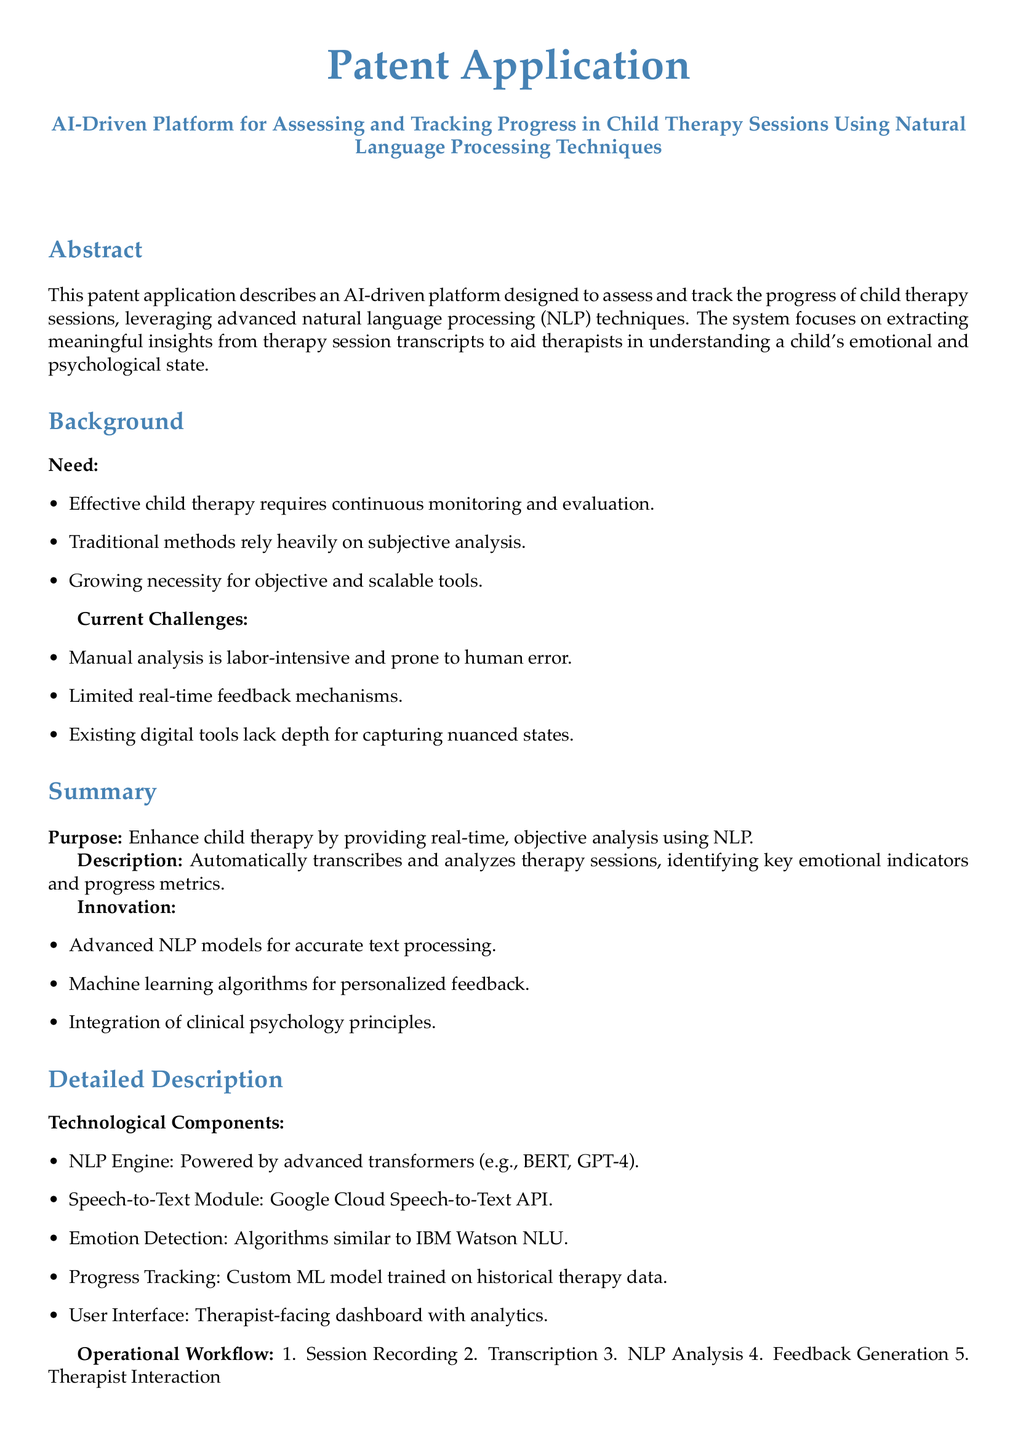What is the title of the patent application? The title is explicitly mentioned at the beginning of the document as "AI-Driven Platform for Assessing and Tracking Progress in Child Therapy Sessions Using Natural Language Processing Techniques".
Answer: AI-Driven Platform for Assessing and Tracking Progress in Child Therapy Sessions Using Natural Language Processing Techniques What technology powers the NLP Engine? The NLP Engine is powered by advanced transformers, specifically noted as BERT and GPT-4 in the document.
Answer: BERT, GPT-4 What is identified as a current challenge in child therapy? The document lists several current challenges, including manual analysis being labor-intensive and prone to human error.
Answer: Manual analysis being labor-intensive and prone to human error What therapy-related purpose does the platform aim to enhance? The purpose specified in the document is to enhance child therapy by providing real-time, objective analysis using NLP.
Answer: Real-time, objective analysis How many steps are in the operational workflow? There are five distinct steps outlined in the operational workflow of the document.
Answer: Five What advantage does the platform provide over traditional methods? One of the mentioned advantages is that it offers objective insights, reducing subjectivity in therapy evaluations.
Answer: Objective insights reducing subjectivity What type of algorithms are used for personalized feedback? The document specifies that machine learning algorithms are utilized for providing personalized feedback within the platform.
Answer: Machine learning algorithms What module is used for transcription in the platform? The Speech-to-Text Module for transcription is identified as the Google Cloud Speech-to-Text API in the document.
Answer: Google Cloud Speech-to-Text API 